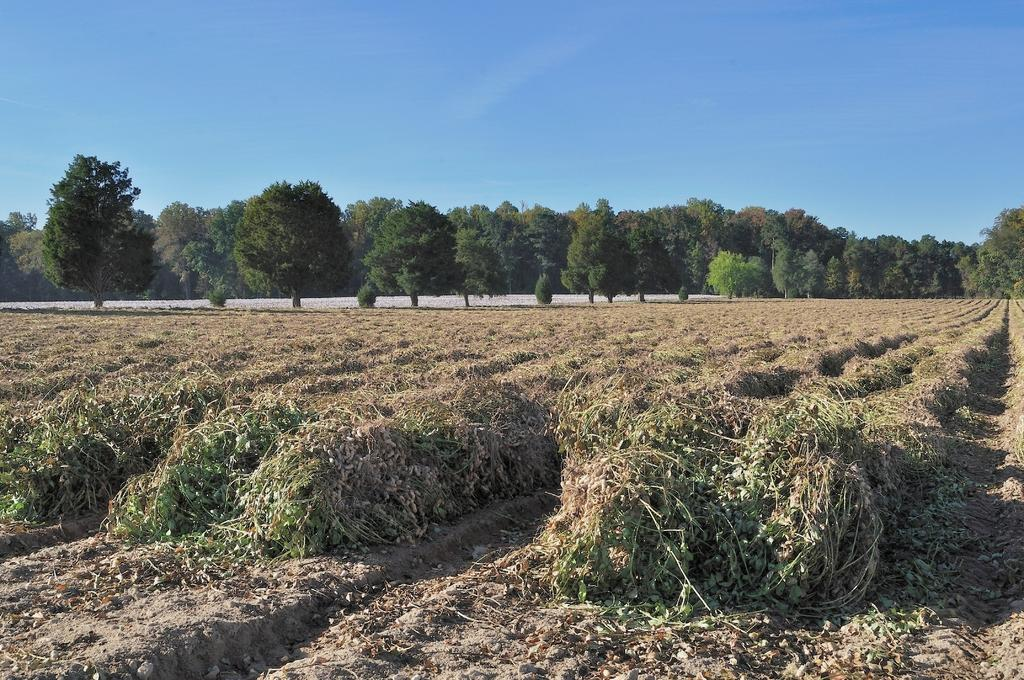What is happening to the plants in the image? The plants have been removed from the ground in the image. What can be seen in the middle of the image? There are trees in the middle of the image. What is visible at the top of the image? The sky is visible at the top of the image. What type of vest is the girl wearing in the image? There is no girl or vest present in the image. 